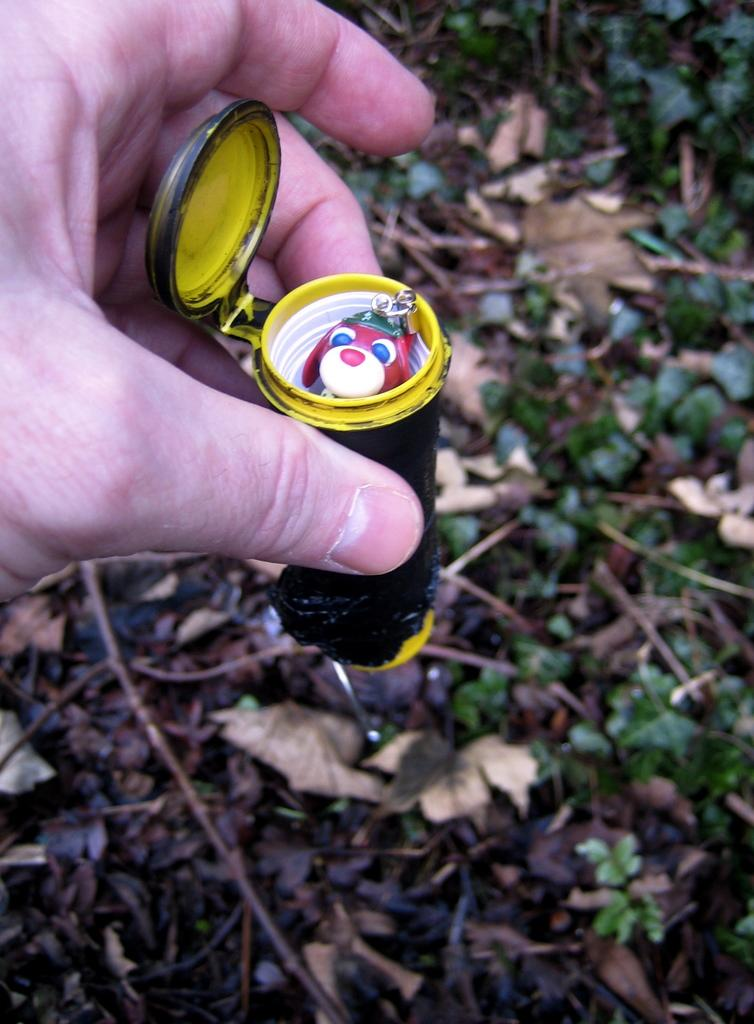What is the person holding in the image? The hand of a person is holding a box in the image. What is inside the box? The box contains a toy. What can be seen in the background of the image? There are plants visible in the background of the image. How many girls are balancing on the toy in the image? There are no girls present in the image, and the toy is not being used for balancing. 